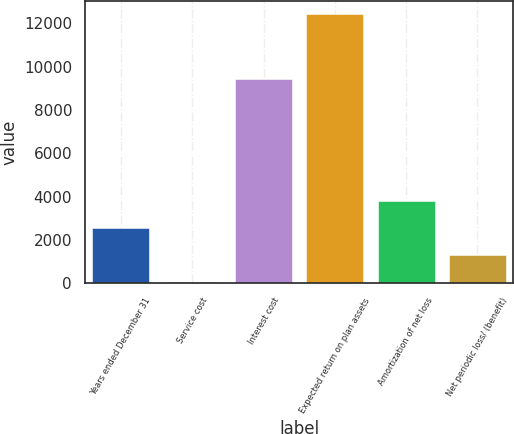Convert chart to OTSL. <chart><loc_0><loc_0><loc_500><loc_500><bar_chart><fcel>Years ended December 31<fcel>Service cost<fcel>Interest cost<fcel>Expected return on plan assets<fcel>Amortization of net loss<fcel>Net periodic loss/ (benefit)<nl><fcel>2545.4<fcel>74<fcel>9427<fcel>12431<fcel>3781.1<fcel>1309.7<nl></chart> 